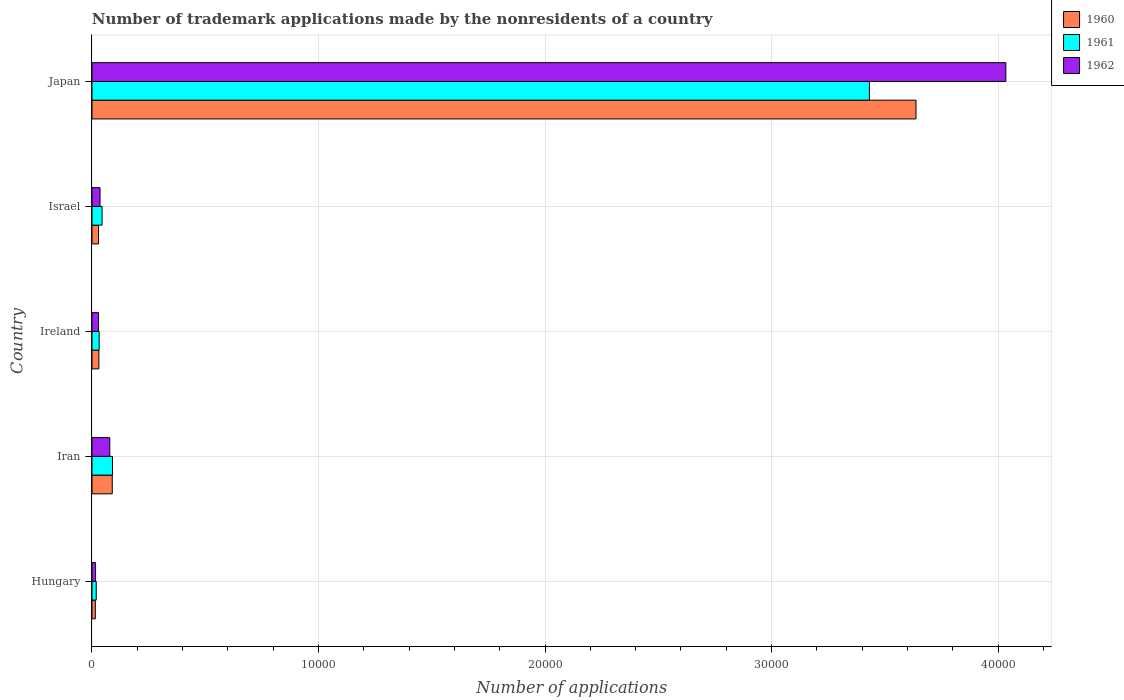How many different coloured bars are there?
Your response must be concise. 3. How many groups of bars are there?
Your response must be concise. 5. Are the number of bars per tick equal to the number of legend labels?
Provide a short and direct response. Yes. What is the number of trademark applications made by the nonresidents in 1962 in Israel?
Offer a very short reply. 355. Across all countries, what is the maximum number of trademark applications made by the nonresidents in 1962?
Offer a terse response. 4.03e+04. Across all countries, what is the minimum number of trademark applications made by the nonresidents in 1962?
Ensure brevity in your answer.  158. In which country was the number of trademark applications made by the nonresidents in 1960 minimum?
Give a very brief answer. Hungary. What is the total number of trademark applications made by the nonresidents in 1962 in the graph?
Make the answer very short. 4.19e+04. What is the difference between the number of trademark applications made by the nonresidents in 1960 in Iran and that in Japan?
Your answer should be compact. -3.55e+04. What is the difference between the number of trademark applications made by the nonresidents in 1961 in Iran and the number of trademark applications made by the nonresidents in 1960 in Hungary?
Provide a succinct answer. 758. What is the average number of trademark applications made by the nonresidents in 1961 per country?
Your answer should be compact. 7235. In how many countries, is the number of trademark applications made by the nonresidents in 1960 greater than 14000 ?
Provide a succinct answer. 1. What is the ratio of the number of trademark applications made by the nonresidents in 1960 in Iran to that in Ireland?
Your answer should be compact. 2.93. What is the difference between the highest and the second highest number of trademark applications made by the nonresidents in 1961?
Offer a very short reply. 3.34e+04. What is the difference between the highest and the lowest number of trademark applications made by the nonresidents in 1961?
Ensure brevity in your answer.  3.41e+04. In how many countries, is the number of trademark applications made by the nonresidents in 1961 greater than the average number of trademark applications made by the nonresidents in 1961 taken over all countries?
Offer a terse response. 1. Is the sum of the number of trademark applications made by the nonresidents in 1960 in Iran and Israel greater than the maximum number of trademark applications made by the nonresidents in 1961 across all countries?
Provide a short and direct response. No. How many bars are there?
Provide a short and direct response. 15. Are all the bars in the graph horizontal?
Offer a very short reply. Yes. Does the graph contain any zero values?
Give a very brief answer. No. Does the graph contain grids?
Give a very brief answer. Yes. Where does the legend appear in the graph?
Provide a succinct answer. Top right. How many legend labels are there?
Provide a short and direct response. 3. What is the title of the graph?
Your answer should be very brief. Number of trademark applications made by the nonresidents of a country. What is the label or title of the X-axis?
Your answer should be very brief. Number of applications. What is the Number of applications in 1960 in Hungary?
Your answer should be compact. 147. What is the Number of applications in 1961 in Hungary?
Your answer should be compact. 188. What is the Number of applications of 1962 in Hungary?
Ensure brevity in your answer.  158. What is the Number of applications in 1960 in Iran?
Your answer should be compact. 895. What is the Number of applications of 1961 in Iran?
Keep it short and to the point. 905. What is the Number of applications in 1962 in Iran?
Offer a very short reply. 786. What is the Number of applications of 1960 in Ireland?
Offer a terse response. 305. What is the Number of applications of 1961 in Ireland?
Your response must be concise. 316. What is the Number of applications in 1962 in Ireland?
Keep it short and to the point. 288. What is the Number of applications of 1960 in Israel?
Offer a terse response. 290. What is the Number of applications of 1961 in Israel?
Make the answer very short. 446. What is the Number of applications in 1962 in Israel?
Provide a succinct answer. 355. What is the Number of applications in 1960 in Japan?
Make the answer very short. 3.64e+04. What is the Number of applications of 1961 in Japan?
Your answer should be compact. 3.43e+04. What is the Number of applications in 1962 in Japan?
Ensure brevity in your answer.  4.03e+04. Across all countries, what is the maximum Number of applications of 1960?
Give a very brief answer. 3.64e+04. Across all countries, what is the maximum Number of applications in 1961?
Provide a short and direct response. 3.43e+04. Across all countries, what is the maximum Number of applications in 1962?
Provide a succinct answer. 4.03e+04. Across all countries, what is the minimum Number of applications of 1960?
Keep it short and to the point. 147. Across all countries, what is the minimum Number of applications of 1961?
Keep it short and to the point. 188. Across all countries, what is the minimum Number of applications in 1962?
Give a very brief answer. 158. What is the total Number of applications in 1960 in the graph?
Make the answer very short. 3.80e+04. What is the total Number of applications of 1961 in the graph?
Keep it short and to the point. 3.62e+04. What is the total Number of applications in 1962 in the graph?
Provide a succinct answer. 4.19e+04. What is the difference between the Number of applications of 1960 in Hungary and that in Iran?
Provide a short and direct response. -748. What is the difference between the Number of applications in 1961 in Hungary and that in Iran?
Provide a short and direct response. -717. What is the difference between the Number of applications of 1962 in Hungary and that in Iran?
Keep it short and to the point. -628. What is the difference between the Number of applications in 1960 in Hungary and that in Ireland?
Offer a very short reply. -158. What is the difference between the Number of applications in 1961 in Hungary and that in Ireland?
Your answer should be very brief. -128. What is the difference between the Number of applications in 1962 in Hungary and that in Ireland?
Make the answer very short. -130. What is the difference between the Number of applications of 1960 in Hungary and that in Israel?
Offer a very short reply. -143. What is the difference between the Number of applications in 1961 in Hungary and that in Israel?
Provide a short and direct response. -258. What is the difference between the Number of applications in 1962 in Hungary and that in Israel?
Offer a terse response. -197. What is the difference between the Number of applications of 1960 in Hungary and that in Japan?
Provide a succinct answer. -3.62e+04. What is the difference between the Number of applications in 1961 in Hungary and that in Japan?
Make the answer very short. -3.41e+04. What is the difference between the Number of applications in 1962 in Hungary and that in Japan?
Provide a short and direct response. -4.02e+04. What is the difference between the Number of applications in 1960 in Iran and that in Ireland?
Keep it short and to the point. 590. What is the difference between the Number of applications of 1961 in Iran and that in Ireland?
Offer a terse response. 589. What is the difference between the Number of applications of 1962 in Iran and that in Ireland?
Your answer should be very brief. 498. What is the difference between the Number of applications in 1960 in Iran and that in Israel?
Ensure brevity in your answer.  605. What is the difference between the Number of applications in 1961 in Iran and that in Israel?
Your answer should be compact. 459. What is the difference between the Number of applications of 1962 in Iran and that in Israel?
Provide a succinct answer. 431. What is the difference between the Number of applications of 1960 in Iran and that in Japan?
Your answer should be compact. -3.55e+04. What is the difference between the Number of applications of 1961 in Iran and that in Japan?
Give a very brief answer. -3.34e+04. What is the difference between the Number of applications in 1962 in Iran and that in Japan?
Ensure brevity in your answer.  -3.96e+04. What is the difference between the Number of applications of 1960 in Ireland and that in Israel?
Keep it short and to the point. 15. What is the difference between the Number of applications in 1961 in Ireland and that in Israel?
Your answer should be very brief. -130. What is the difference between the Number of applications of 1962 in Ireland and that in Israel?
Ensure brevity in your answer.  -67. What is the difference between the Number of applications in 1960 in Ireland and that in Japan?
Your response must be concise. -3.61e+04. What is the difference between the Number of applications in 1961 in Ireland and that in Japan?
Offer a very short reply. -3.40e+04. What is the difference between the Number of applications of 1962 in Ireland and that in Japan?
Offer a very short reply. -4.01e+04. What is the difference between the Number of applications of 1960 in Israel and that in Japan?
Keep it short and to the point. -3.61e+04. What is the difference between the Number of applications in 1961 in Israel and that in Japan?
Ensure brevity in your answer.  -3.39e+04. What is the difference between the Number of applications of 1962 in Israel and that in Japan?
Ensure brevity in your answer.  -4.00e+04. What is the difference between the Number of applications of 1960 in Hungary and the Number of applications of 1961 in Iran?
Your answer should be very brief. -758. What is the difference between the Number of applications of 1960 in Hungary and the Number of applications of 1962 in Iran?
Offer a terse response. -639. What is the difference between the Number of applications of 1961 in Hungary and the Number of applications of 1962 in Iran?
Provide a succinct answer. -598. What is the difference between the Number of applications in 1960 in Hungary and the Number of applications in 1961 in Ireland?
Make the answer very short. -169. What is the difference between the Number of applications in 1960 in Hungary and the Number of applications in 1962 in Ireland?
Provide a succinct answer. -141. What is the difference between the Number of applications in 1961 in Hungary and the Number of applications in 1962 in Ireland?
Your answer should be very brief. -100. What is the difference between the Number of applications of 1960 in Hungary and the Number of applications of 1961 in Israel?
Your answer should be very brief. -299. What is the difference between the Number of applications in 1960 in Hungary and the Number of applications in 1962 in Israel?
Your answer should be compact. -208. What is the difference between the Number of applications of 1961 in Hungary and the Number of applications of 1962 in Israel?
Ensure brevity in your answer.  -167. What is the difference between the Number of applications in 1960 in Hungary and the Number of applications in 1961 in Japan?
Offer a very short reply. -3.42e+04. What is the difference between the Number of applications of 1960 in Hungary and the Number of applications of 1962 in Japan?
Your answer should be very brief. -4.02e+04. What is the difference between the Number of applications in 1961 in Hungary and the Number of applications in 1962 in Japan?
Make the answer very short. -4.02e+04. What is the difference between the Number of applications of 1960 in Iran and the Number of applications of 1961 in Ireland?
Ensure brevity in your answer.  579. What is the difference between the Number of applications of 1960 in Iran and the Number of applications of 1962 in Ireland?
Offer a very short reply. 607. What is the difference between the Number of applications in 1961 in Iran and the Number of applications in 1962 in Ireland?
Make the answer very short. 617. What is the difference between the Number of applications of 1960 in Iran and the Number of applications of 1961 in Israel?
Make the answer very short. 449. What is the difference between the Number of applications in 1960 in Iran and the Number of applications in 1962 in Israel?
Make the answer very short. 540. What is the difference between the Number of applications of 1961 in Iran and the Number of applications of 1962 in Israel?
Your answer should be compact. 550. What is the difference between the Number of applications of 1960 in Iran and the Number of applications of 1961 in Japan?
Offer a very short reply. -3.34e+04. What is the difference between the Number of applications of 1960 in Iran and the Number of applications of 1962 in Japan?
Offer a very short reply. -3.94e+04. What is the difference between the Number of applications in 1961 in Iran and the Number of applications in 1962 in Japan?
Offer a very short reply. -3.94e+04. What is the difference between the Number of applications of 1960 in Ireland and the Number of applications of 1961 in Israel?
Keep it short and to the point. -141. What is the difference between the Number of applications in 1961 in Ireland and the Number of applications in 1962 in Israel?
Offer a terse response. -39. What is the difference between the Number of applications of 1960 in Ireland and the Number of applications of 1961 in Japan?
Keep it short and to the point. -3.40e+04. What is the difference between the Number of applications in 1960 in Ireland and the Number of applications in 1962 in Japan?
Offer a terse response. -4.00e+04. What is the difference between the Number of applications of 1961 in Ireland and the Number of applications of 1962 in Japan?
Your answer should be very brief. -4.00e+04. What is the difference between the Number of applications of 1960 in Israel and the Number of applications of 1961 in Japan?
Keep it short and to the point. -3.40e+04. What is the difference between the Number of applications of 1960 in Israel and the Number of applications of 1962 in Japan?
Give a very brief answer. -4.01e+04. What is the difference between the Number of applications of 1961 in Israel and the Number of applications of 1962 in Japan?
Keep it short and to the point. -3.99e+04. What is the average Number of applications in 1960 per country?
Keep it short and to the point. 7602.8. What is the average Number of applications in 1961 per country?
Offer a very short reply. 7235. What is the average Number of applications of 1962 per country?
Provide a short and direct response. 8386. What is the difference between the Number of applications of 1960 and Number of applications of 1961 in Hungary?
Your answer should be very brief. -41. What is the difference between the Number of applications in 1960 and Number of applications in 1961 in Iran?
Keep it short and to the point. -10. What is the difference between the Number of applications of 1960 and Number of applications of 1962 in Iran?
Your response must be concise. 109. What is the difference between the Number of applications in 1961 and Number of applications in 1962 in Iran?
Your answer should be compact. 119. What is the difference between the Number of applications of 1961 and Number of applications of 1962 in Ireland?
Offer a terse response. 28. What is the difference between the Number of applications of 1960 and Number of applications of 1961 in Israel?
Your answer should be compact. -156. What is the difference between the Number of applications of 1960 and Number of applications of 1962 in Israel?
Offer a terse response. -65. What is the difference between the Number of applications in 1961 and Number of applications in 1962 in Israel?
Give a very brief answer. 91. What is the difference between the Number of applications of 1960 and Number of applications of 1961 in Japan?
Ensure brevity in your answer.  2057. What is the difference between the Number of applications of 1960 and Number of applications of 1962 in Japan?
Offer a very short reply. -3966. What is the difference between the Number of applications of 1961 and Number of applications of 1962 in Japan?
Your answer should be very brief. -6023. What is the ratio of the Number of applications of 1960 in Hungary to that in Iran?
Provide a succinct answer. 0.16. What is the ratio of the Number of applications of 1961 in Hungary to that in Iran?
Your response must be concise. 0.21. What is the ratio of the Number of applications of 1962 in Hungary to that in Iran?
Your answer should be compact. 0.2. What is the ratio of the Number of applications of 1960 in Hungary to that in Ireland?
Your response must be concise. 0.48. What is the ratio of the Number of applications in 1961 in Hungary to that in Ireland?
Keep it short and to the point. 0.59. What is the ratio of the Number of applications of 1962 in Hungary to that in Ireland?
Provide a succinct answer. 0.55. What is the ratio of the Number of applications of 1960 in Hungary to that in Israel?
Ensure brevity in your answer.  0.51. What is the ratio of the Number of applications in 1961 in Hungary to that in Israel?
Your answer should be compact. 0.42. What is the ratio of the Number of applications of 1962 in Hungary to that in Israel?
Ensure brevity in your answer.  0.45. What is the ratio of the Number of applications in 1960 in Hungary to that in Japan?
Offer a terse response. 0. What is the ratio of the Number of applications in 1961 in Hungary to that in Japan?
Offer a very short reply. 0.01. What is the ratio of the Number of applications in 1962 in Hungary to that in Japan?
Provide a short and direct response. 0. What is the ratio of the Number of applications of 1960 in Iran to that in Ireland?
Ensure brevity in your answer.  2.93. What is the ratio of the Number of applications of 1961 in Iran to that in Ireland?
Your answer should be compact. 2.86. What is the ratio of the Number of applications in 1962 in Iran to that in Ireland?
Provide a short and direct response. 2.73. What is the ratio of the Number of applications of 1960 in Iran to that in Israel?
Give a very brief answer. 3.09. What is the ratio of the Number of applications of 1961 in Iran to that in Israel?
Ensure brevity in your answer.  2.03. What is the ratio of the Number of applications of 1962 in Iran to that in Israel?
Give a very brief answer. 2.21. What is the ratio of the Number of applications in 1960 in Iran to that in Japan?
Your response must be concise. 0.02. What is the ratio of the Number of applications in 1961 in Iran to that in Japan?
Your answer should be very brief. 0.03. What is the ratio of the Number of applications of 1962 in Iran to that in Japan?
Make the answer very short. 0.02. What is the ratio of the Number of applications in 1960 in Ireland to that in Israel?
Provide a short and direct response. 1.05. What is the ratio of the Number of applications in 1961 in Ireland to that in Israel?
Keep it short and to the point. 0.71. What is the ratio of the Number of applications of 1962 in Ireland to that in Israel?
Make the answer very short. 0.81. What is the ratio of the Number of applications of 1960 in Ireland to that in Japan?
Offer a terse response. 0.01. What is the ratio of the Number of applications in 1961 in Ireland to that in Japan?
Your answer should be very brief. 0.01. What is the ratio of the Number of applications in 1962 in Ireland to that in Japan?
Give a very brief answer. 0.01. What is the ratio of the Number of applications of 1960 in Israel to that in Japan?
Your answer should be compact. 0.01. What is the ratio of the Number of applications in 1961 in Israel to that in Japan?
Keep it short and to the point. 0.01. What is the ratio of the Number of applications of 1962 in Israel to that in Japan?
Keep it short and to the point. 0.01. What is the difference between the highest and the second highest Number of applications in 1960?
Ensure brevity in your answer.  3.55e+04. What is the difference between the highest and the second highest Number of applications in 1961?
Provide a succinct answer. 3.34e+04. What is the difference between the highest and the second highest Number of applications of 1962?
Offer a terse response. 3.96e+04. What is the difference between the highest and the lowest Number of applications in 1960?
Ensure brevity in your answer.  3.62e+04. What is the difference between the highest and the lowest Number of applications of 1961?
Provide a short and direct response. 3.41e+04. What is the difference between the highest and the lowest Number of applications of 1962?
Give a very brief answer. 4.02e+04. 